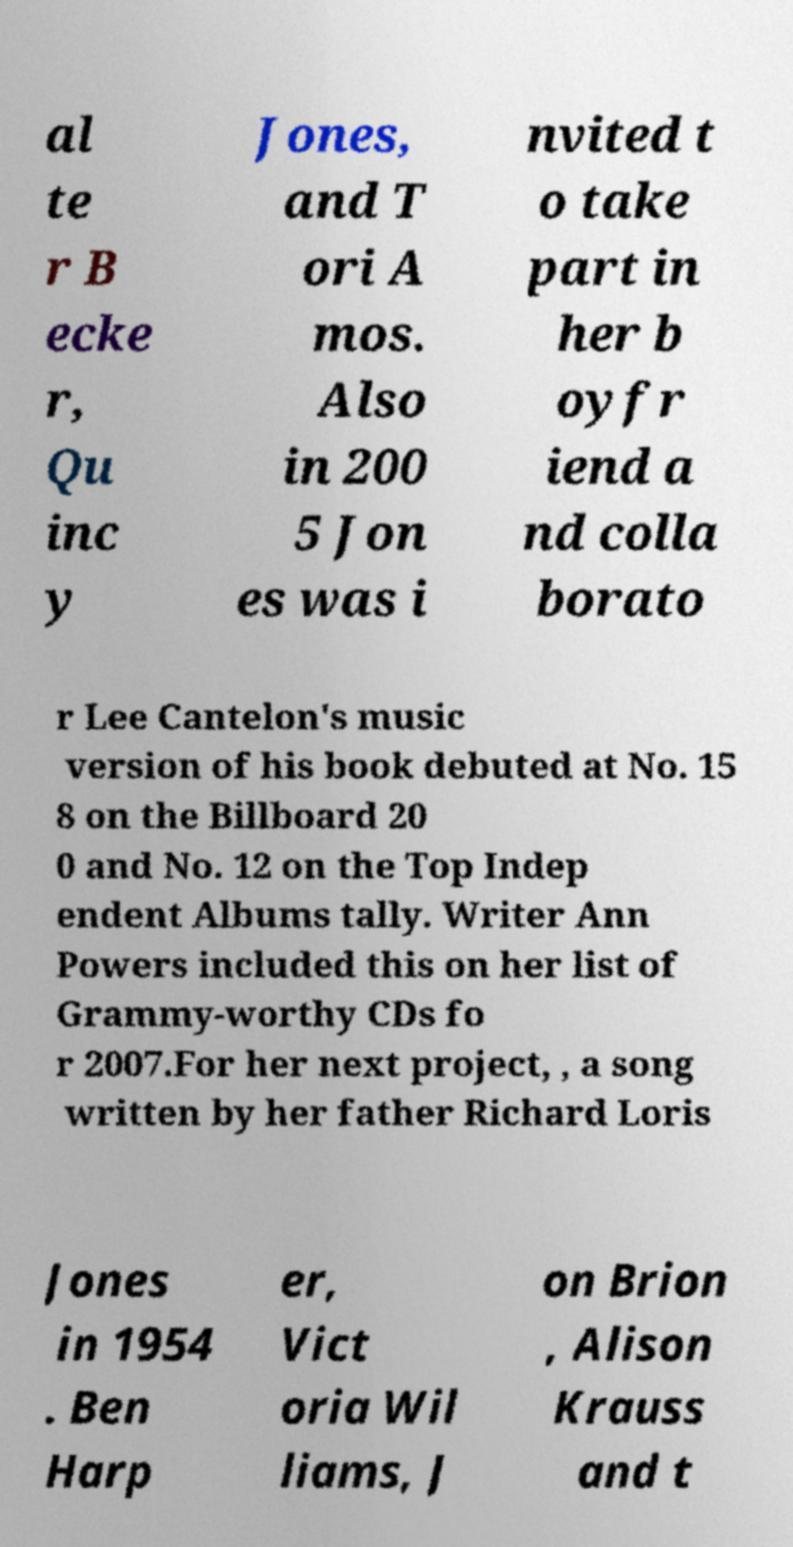I need the written content from this picture converted into text. Can you do that? al te r B ecke r, Qu inc y Jones, and T ori A mos. Also in 200 5 Jon es was i nvited t o take part in her b oyfr iend a nd colla borato r Lee Cantelon's music version of his book debuted at No. 15 8 on the Billboard 20 0 and No. 12 on the Top Indep endent Albums tally. Writer Ann Powers included this on her list of Grammy-worthy CDs fo r 2007.For her next project, , a song written by her father Richard Loris Jones in 1954 . Ben Harp er, Vict oria Wil liams, J on Brion , Alison Krauss and t 